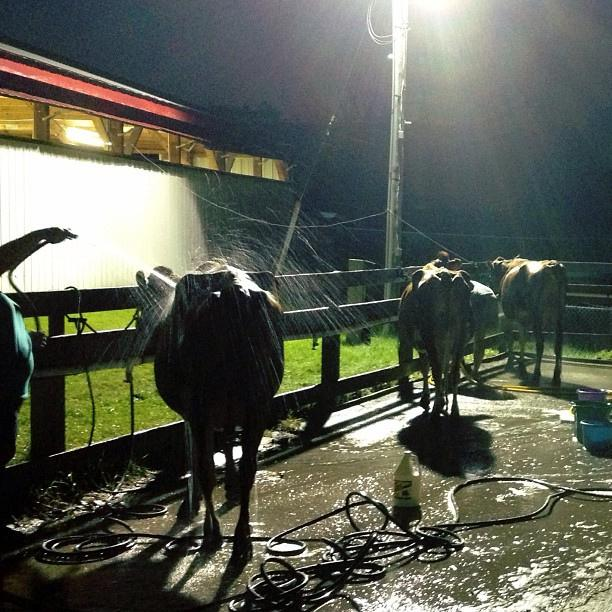What is happening in the photo? cleaning 